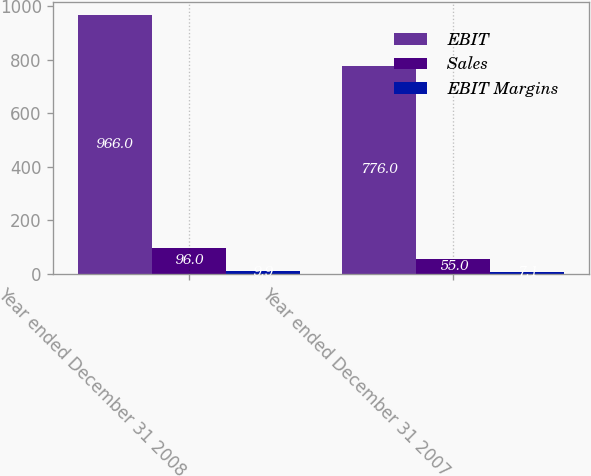Convert chart. <chart><loc_0><loc_0><loc_500><loc_500><stacked_bar_chart><ecel><fcel>Year ended December 31 2008<fcel>Year ended December 31 2007<nl><fcel>EBIT<fcel>966<fcel>776<nl><fcel>Sales<fcel>96<fcel>55<nl><fcel>EBIT Margins<fcel>9.9<fcel>7.1<nl></chart> 